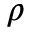Convert formula to latex. <formula><loc_0><loc_0><loc_500><loc_500>\rho</formula> 